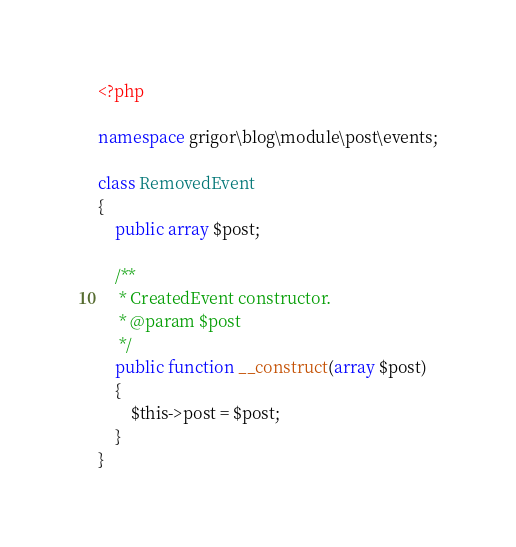<code> <loc_0><loc_0><loc_500><loc_500><_PHP_><?php

namespace grigor\blog\module\post\events;

class RemovedEvent
{
    public array $post;

    /**
     * CreatedEvent constructor.
     * @param $post
     */
    public function __construct(array $post)
    {
        $this->post = $post;
    }
}</code> 